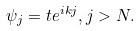<formula> <loc_0><loc_0><loc_500><loc_500>\psi _ { j } = t e ^ { i k j } , j > N .</formula> 